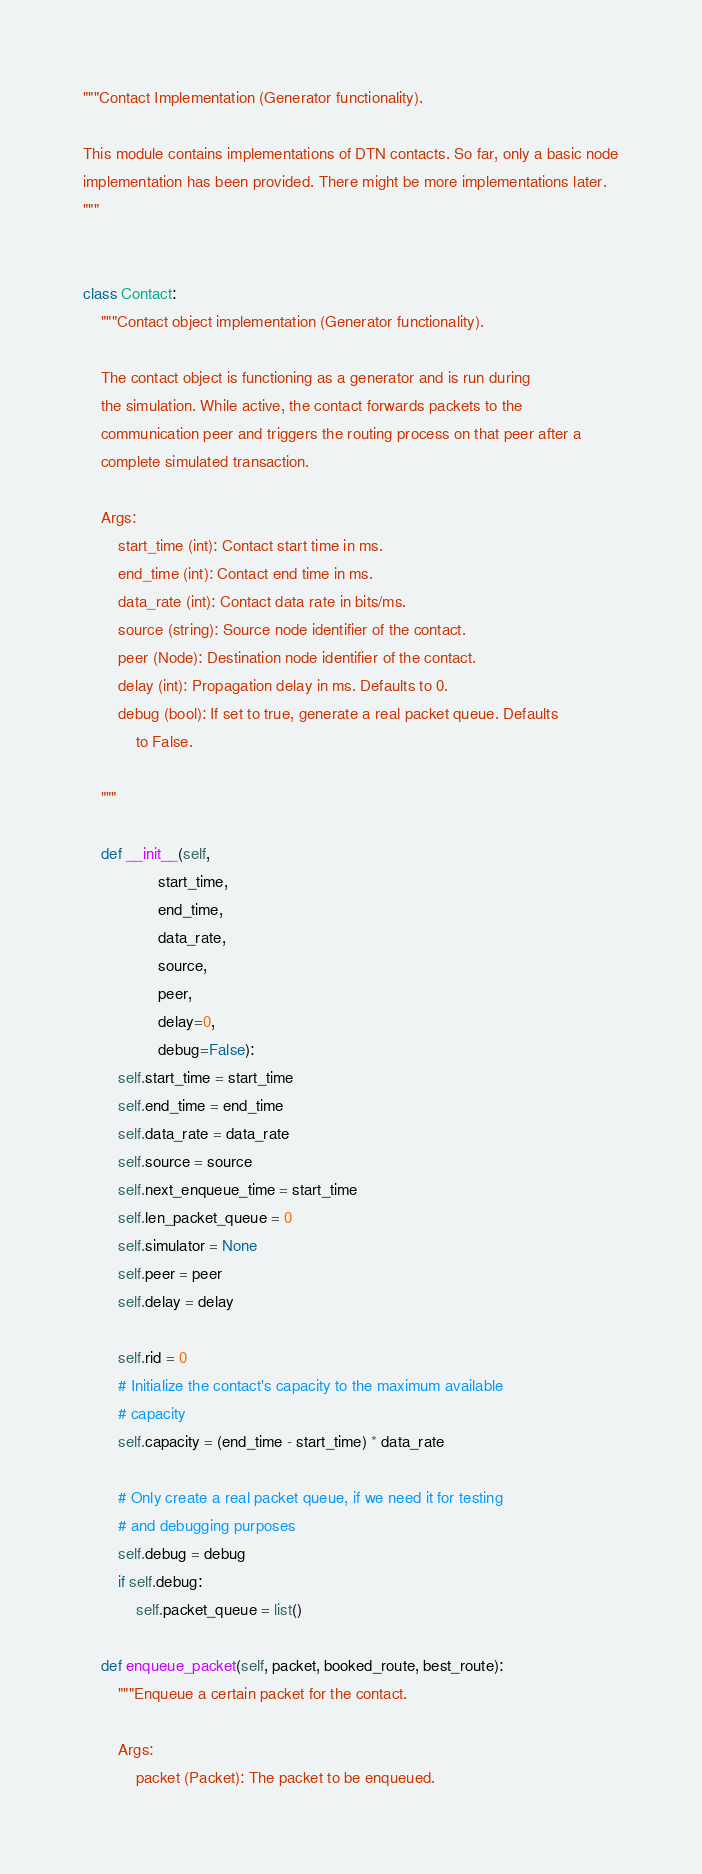Convert code to text. <code><loc_0><loc_0><loc_500><loc_500><_Python_>"""Contact Implementation (Generator functionality).

This module contains implementations of DTN contacts. So far, only a basic node
implementation has been provided. There might be more implementations later.
"""


class Contact:
    """Contact object implementation (Generator functionality).

    The contact object is functioning as a generator and is run during
    the simulation. While active, the contact forwards packets to the
    communication peer and triggers the routing process on that peer after a
    complete simulated transaction.

    Args:
        start_time (int): Contact start time in ms.
        end_time (int): Contact end time in ms.
        data_rate (int): Contact data rate in bits/ms.
        source (string): Source node identifier of the contact.
        peer (Node): Destination node identifier of the contact.
        delay (int): Propagation delay in ms. Defaults to 0.
        debug (bool): If set to true, generate a real packet queue. Defaults
            to False.

    """

    def __init__(self,
                 start_time,
                 end_time,
                 data_rate,
                 source,
                 peer,
                 delay=0,
                 debug=False):
        self.start_time = start_time
        self.end_time = end_time
        self.data_rate = data_rate
        self.source = source
        self.next_enqueue_time = start_time
        self.len_packet_queue = 0
        self.simulator = None
        self.peer = peer
        self.delay = delay

        self.rid = 0
        # Initialize the contact's capacity to the maximum available
        # capacity
        self.capacity = (end_time - start_time) * data_rate

        # Only create a real packet queue, if we need it for testing
        # and debugging purposes
        self.debug = debug
        if self.debug:
            self.packet_queue = list()

    def enqueue_packet(self, packet, booked_route, best_route):
        """Enqueue a certain packet for the contact.

        Args:
            packet (Packet): The packet to be enqueued.</code> 